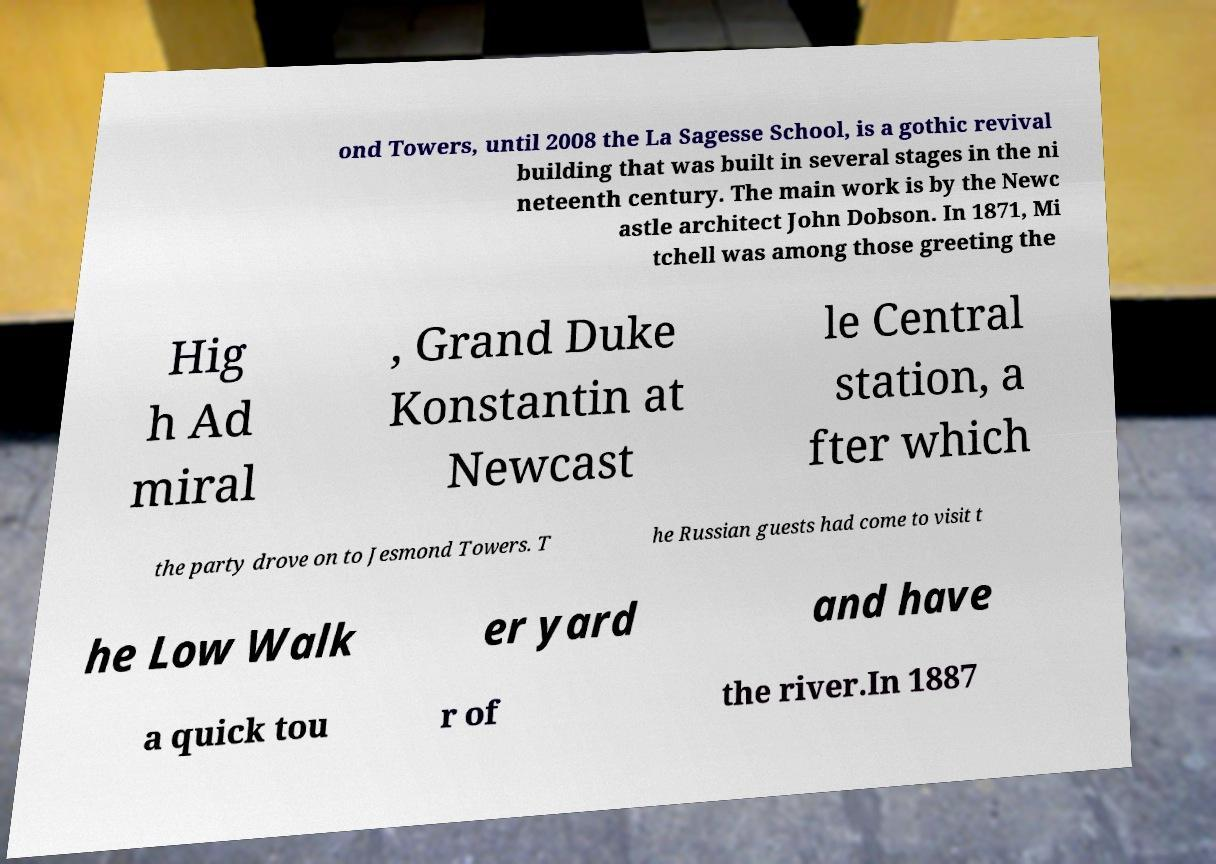Please identify and transcribe the text found in this image. ond Towers, until 2008 the La Sagesse School, is a gothic revival building that was built in several stages in the ni neteenth century. The main work is by the Newc astle architect John Dobson. In 1871, Mi tchell was among those greeting the Hig h Ad miral , Grand Duke Konstantin at Newcast le Central station, a fter which the party drove on to Jesmond Towers. T he Russian guests had come to visit t he Low Walk er yard and have a quick tou r of the river.In 1887 